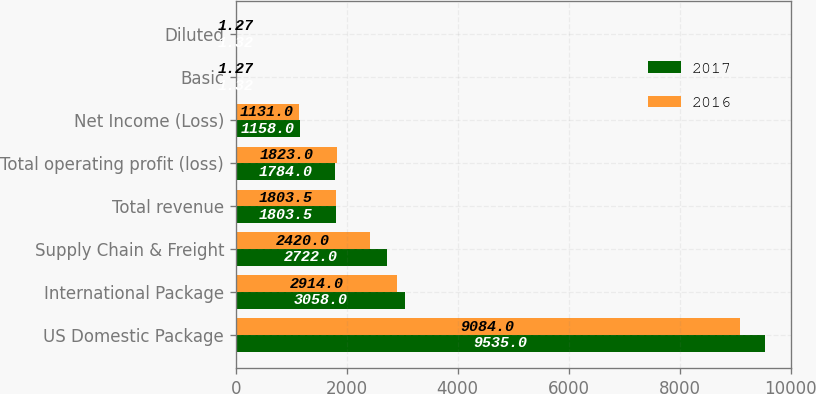Convert chart to OTSL. <chart><loc_0><loc_0><loc_500><loc_500><stacked_bar_chart><ecel><fcel>US Domestic Package<fcel>International Package<fcel>Supply Chain & Freight<fcel>Total revenue<fcel>Total operating profit (loss)<fcel>Net Income (Loss)<fcel>Basic<fcel>Diluted<nl><fcel>2017<fcel>9535<fcel>3058<fcel>2722<fcel>1803.5<fcel>1784<fcel>1158<fcel>1.32<fcel>1.32<nl><fcel>2016<fcel>9084<fcel>2914<fcel>2420<fcel>1803.5<fcel>1823<fcel>1131<fcel>1.27<fcel>1.27<nl></chart> 